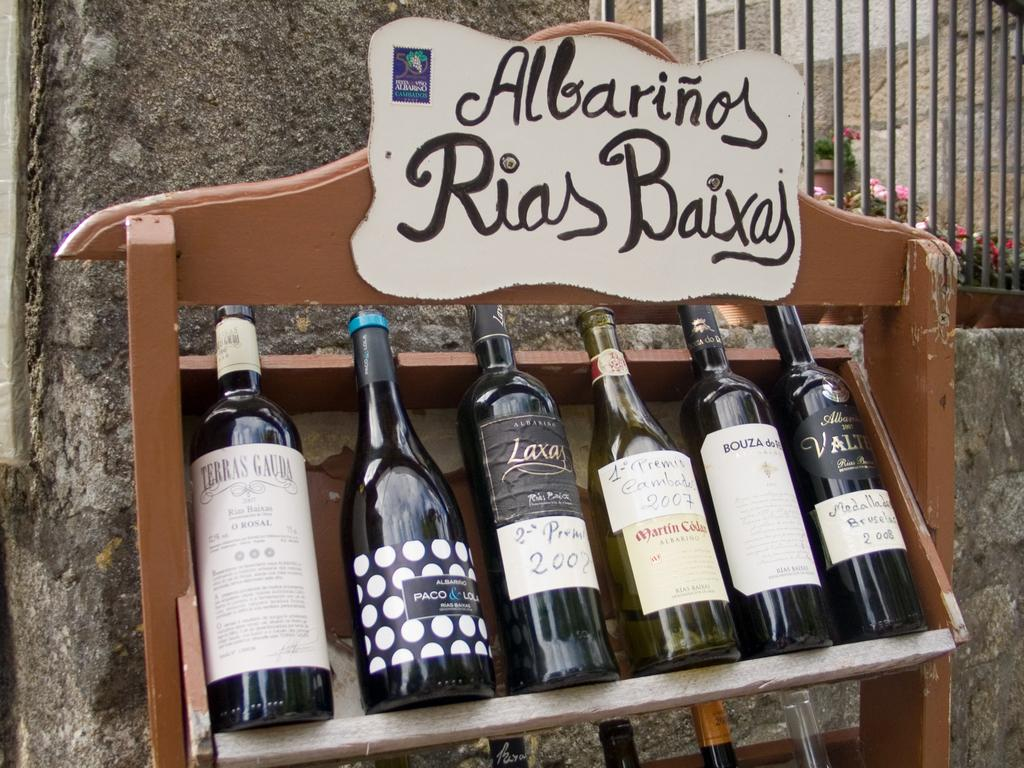<image>
Create a compact narrative representing the image presented. Bottles of wine on a Albarinos Rias Baixaj wine rack. 